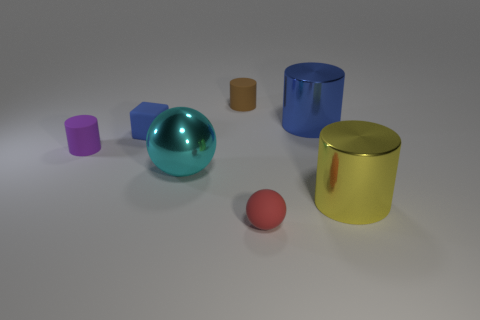What number of cylinders have the same color as the rubber block?
Offer a terse response. 1. Are there any other things that are the same shape as the small blue matte thing?
Offer a very short reply. No. The small rubber cylinder that is left of the large thing on the left side of the small red sphere is what color?
Offer a terse response. Purple. What shape is the cyan object?
Provide a short and direct response. Sphere. There is a metal thing that is in front of the cyan metallic thing; does it have the same size as the small purple matte cylinder?
Give a very brief answer. No. Are there any large green cylinders that have the same material as the small red thing?
Offer a very short reply. No. How many things are small cylinders that are behind the purple thing or tiny matte spheres?
Ensure brevity in your answer.  2. Are any large yellow rubber balls visible?
Your answer should be very brief. No. The thing that is to the right of the rubber sphere and behind the yellow cylinder has what shape?
Make the answer very short. Cylinder. There is a matte object in front of the purple rubber cylinder; how big is it?
Your answer should be compact. Small. 